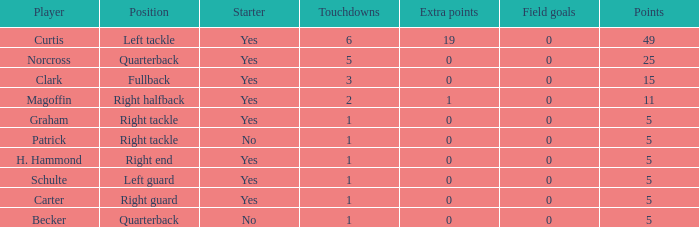Name the extra points for left guard 0.0. Give me the full table as a dictionary. {'header': ['Player', 'Position', 'Starter', 'Touchdowns', 'Extra points', 'Field goals', 'Points'], 'rows': [['Curtis', 'Left tackle', 'Yes', '6', '19', '0', '49'], ['Norcross', 'Quarterback', 'Yes', '5', '0', '0', '25'], ['Clark', 'Fullback', 'Yes', '3', '0', '0', '15'], ['Magoffin', 'Right halfback', 'Yes', '2', '1', '0', '11'], ['Graham', 'Right tackle', 'Yes', '1', '0', '0', '5'], ['Patrick', 'Right tackle', 'No', '1', '0', '0', '5'], ['H. Hammond', 'Right end', 'Yes', '1', '0', '0', '5'], ['Schulte', 'Left guard', 'Yes', '1', '0', '0', '5'], ['Carter', 'Right guard', 'Yes', '1', '0', '0', '5'], ['Becker', 'Quarterback', 'No', '1', '0', '0', '5']]} 